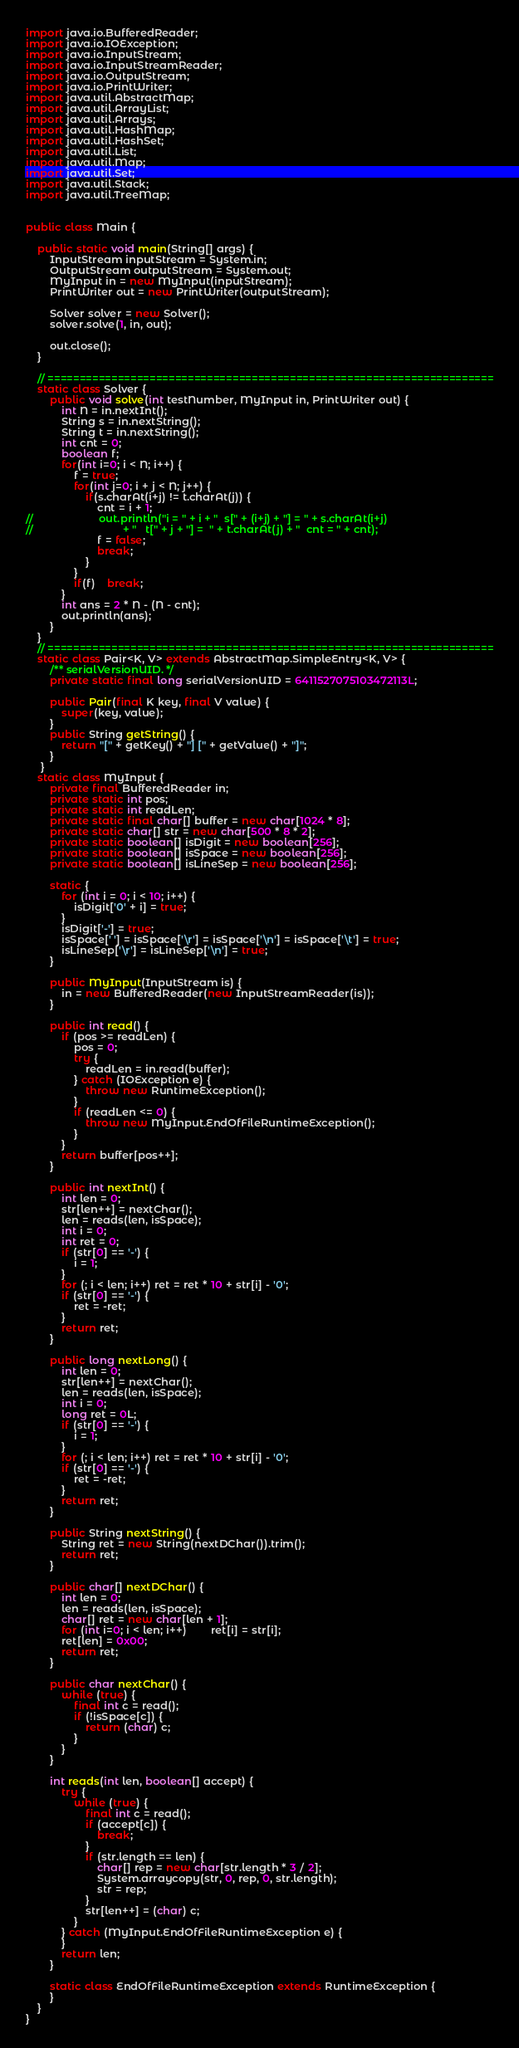<code> <loc_0><loc_0><loc_500><loc_500><_Java_>import java.io.BufferedReader;
import java.io.IOException;
import java.io.InputStream;
import java.io.InputStreamReader;
import java.io.OutputStream;
import java.io.PrintWriter;
import java.util.AbstractMap;
import java.util.ArrayList;
import java.util.Arrays;
import java.util.HashMap;
import java.util.HashSet;
import java.util.List;
import java.util.Map;
import java.util.Set;
import java.util.Stack;
import java.util.TreeMap;


public class Main {
	
	public static void main(String[] args) {
        InputStream inputStream = System.in;
        OutputStream outputStream = System.out;
        MyInput in = new MyInput(inputStream);
        PrintWriter out = new PrintWriter(outputStream);
        
        Solver solver = new Solver();
        solver.solve(1, in, out);
        
        out.close();
    }
    
    // ======================================================================
    static class Solver {
    	public void solve(int testNumber, MyInput in, PrintWriter out) {
    		int N = in.nextInt();
    		String s = in.nextString();
    		String t = in.nextString();
    		int cnt = 0;
    		boolean f;
    		for(int i=0; i < N; i++) {
        		f = true;
    			for(int j=0; i + j < N; j++) {
        			if(s.charAt(i+j) != t.charAt(j)) {
        				cnt = i + 1;
//        				out.println("i = " + i + "  s[" + (i+j) + "] = " + s.charAt(i+j) 
//        						+ "   t[" + j + "] =  " + t.charAt(j) + "  cnt = " + cnt);
        				f = false;
        				break;
        			}
    			}
    			if(f)	break;
    		}
    		int ans = 2 * N - (N - cnt);
   			out.println(ans);
        }
    }
    // ======================================================================
    static class Pair<K, V> extends AbstractMap.SimpleEntry<K, V> {
        /** serialVersionUID. */
        private static final long serialVersionUID = 6411527075103472113L;

        public Pair(final K key, final V value) {
            super(key, value);
        }
        public String getString() {
            return "[" + getKey() + "] [" + getValue() + "]";
        }
     }    
    static class MyInput {
        private final BufferedReader in;
        private static int pos;
        private static int readLen;
        private static final char[] buffer = new char[1024 * 8];
        private static char[] str = new char[500 * 8 * 2];
        private static boolean[] isDigit = new boolean[256];
        private static boolean[] isSpace = new boolean[256];
        private static boolean[] isLineSep = new boolean[256];
 
        static {
            for (int i = 0; i < 10; i++) {
                isDigit['0' + i] = true;
            }
            isDigit['-'] = true;
            isSpace[' '] = isSpace['\r'] = isSpace['\n'] = isSpace['\t'] = true;
            isLineSep['\r'] = isLineSep['\n'] = true;
        }
 
        public MyInput(InputStream is) {
            in = new BufferedReader(new InputStreamReader(is));
        }
 
        public int read() {
            if (pos >= readLen) {
                pos = 0;
                try {
                    readLen = in.read(buffer);
                } catch (IOException e) {
                    throw new RuntimeException();
                }
                if (readLen <= 0) {
                    throw new MyInput.EndOfFileRuntimeException();
                }
            }
            return buffer[pos++];
        }
 
        public int nextInt() {
            int len = 0;
            str[len++] = nextChar();
            len = reads(len, isSpace);
            int i = 0;
            int ret = 0;
            if (str[0] == '-') {
                i = 1;
            }
            for (; i < len; i++) ret = ret * 10 + str[i] - '0';
            if (str[0] == '-') {
                ret = -ret;
            }
            return ret;
        }
 
        public long nextLong() {
            int len = 0;
            str[len++] = nextChar();
            len = reads(len, isSpace);
            int i = 0;
            long ret = 0L;
            if (str[0] == '-') {
                i = 1;
            }
            for (; i < len; i++) ret = ret * 10 + str[i] - '0';
            if (str[0] == '-') {
                ret = -ret;
            }
            return ret;
        }
 
        public String nextString() {
        	String ret = new String(nextDChar()).trim();
            return ret;
        }
 
        public char[] nextDChar() {
            int len = 0;
            len = reads(len, isSpace);
            char[] ret = new char[len + 1];
            for (int i=0; i < len; i++)		ret[i] = str[i];
            ret[len] = 0x00;
            return ret;
        }
 
        public char nextChar() {
            while (true) {
                final int c = read();
                if (!isSpace[c]) {
                    return (char) c;
                }
            }
        }
 
        int reads(int len, boolean[] accept) {
            try {
                while (true) {
                    final int c = read();
                    if (accept[c]) {
                        break;
                    }
                    if (str.length == len) {
                        char[] rep = new char[str.length * 3 / 2];
                        System.arraycopy(str, 0, rep, 0, str.length);
                        str = rep;
                    }
                    str[len++] = (char) c;
                }
            } catch (MyInput.EndOfFileRuntimeException e) {
            }
            return len;
        }
 
        static class EndOfFileRuntimeException extends RuntimeException {
        }
    }
}
</code> 